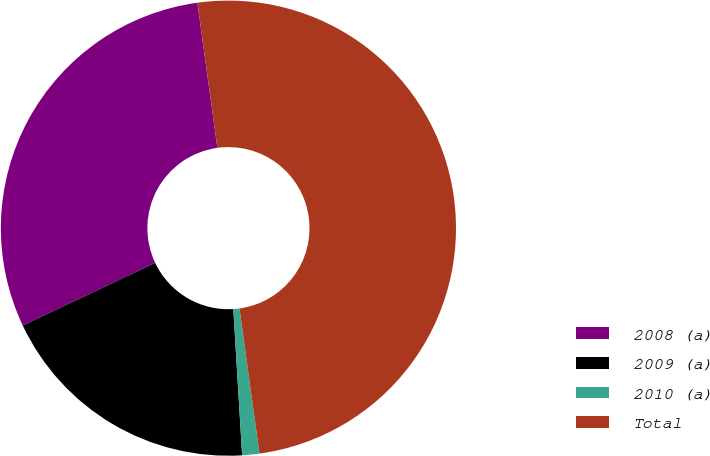<chart> <loc_0><loc_0><loc_500><loc_500><pie_chart><fcel>2008 (a)<fcel>2009 (a)<fcel>2010 (a)<fcel>Total<nl><fcel>29.86%<fcel>18.92%<fcel>1.22%<fcel>50.0%<nl></chart> 